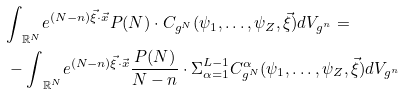<formula> <loc_0><loc_0><loc_500><loc_500>& { \int } _ { \mathbb { R } ^ { N } } e ^ { ( N - n ) \vec { \xi } \cdot \vec { x } } P ( N ) \cdot C _ { g ^ { N } } ( { \psi } _ { 1 } , \dots , { \psi } _ { Z } , \vec { \xi } ) d V _ { g ^ { n } } = \\ & - { \int } _ { \mathbb { R } ^ { N } } e ^ { ( N - n ) \vec { \xi } \cdot \vec { x } } \frac { P ( N ) } { N - n } \cdot { \Sigma } _ { \alpha = 1 } ^ { L - 1 } C ^ { \alpha } _ { g ^ { N } } ( { \psi } _ { 1 } , \dots , { \psi } _ { Z } , \vec { \xi } ) d V _ { g ^ { n } }</formula> 